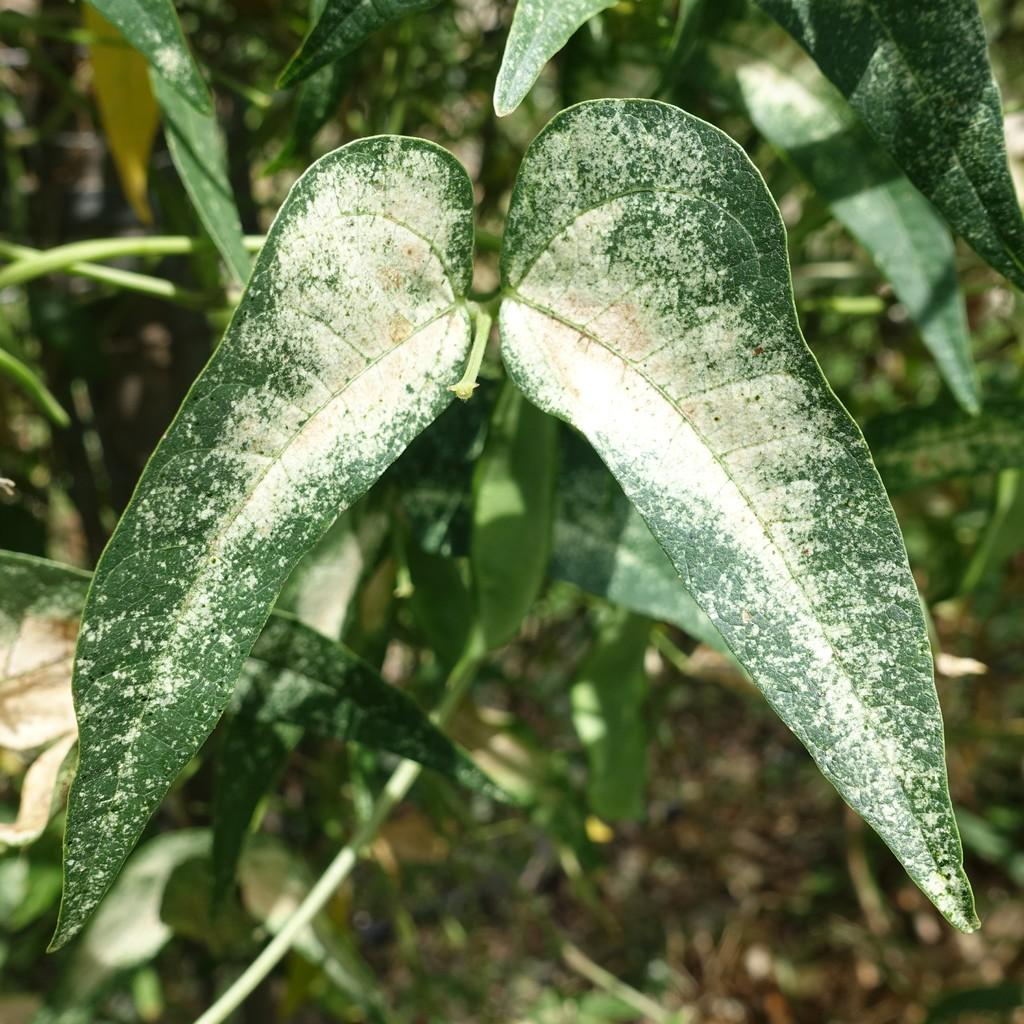What type of vegetation can be seen in the image? There are trees in the image. What is covering the surface in the image? Leaves are present on the surface in the image. Can you see a face on the jar in the image? There is no jar present in the image, so it is not possible to see a face on it. 